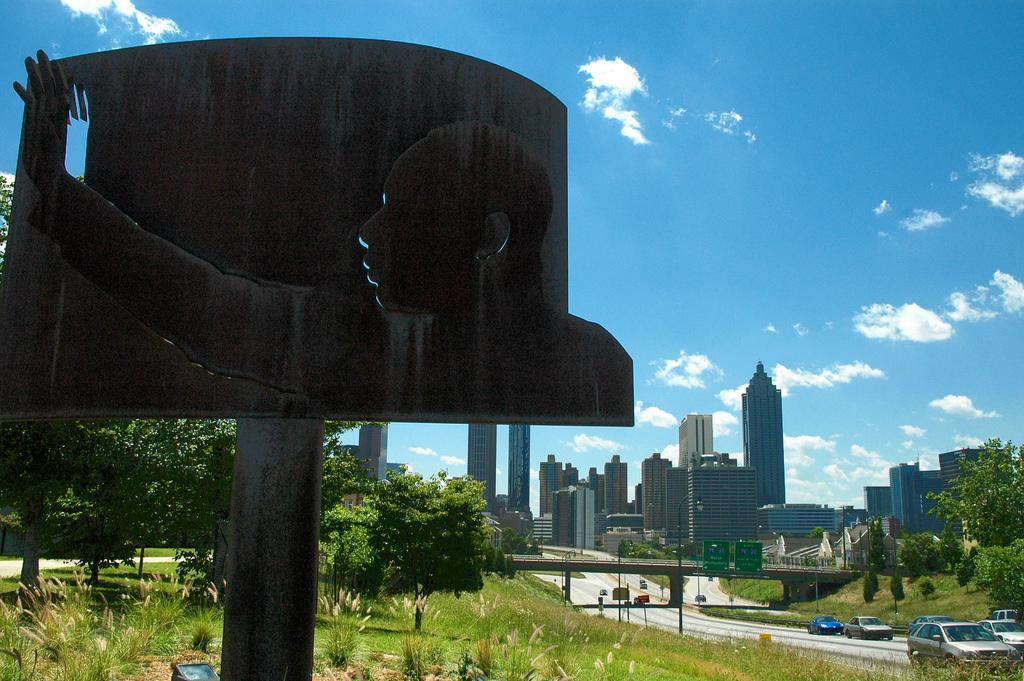Describe this image in one or two sentences. In this image we can see a bird on a pole. In the center of the image we can see a bridge and some poles. On the right side of the image we can see a group of cars parked on the road. At the bottom of the image we can see a box placed on ground, plants and grass. In the background, we can see trees and the cloudy sky. 